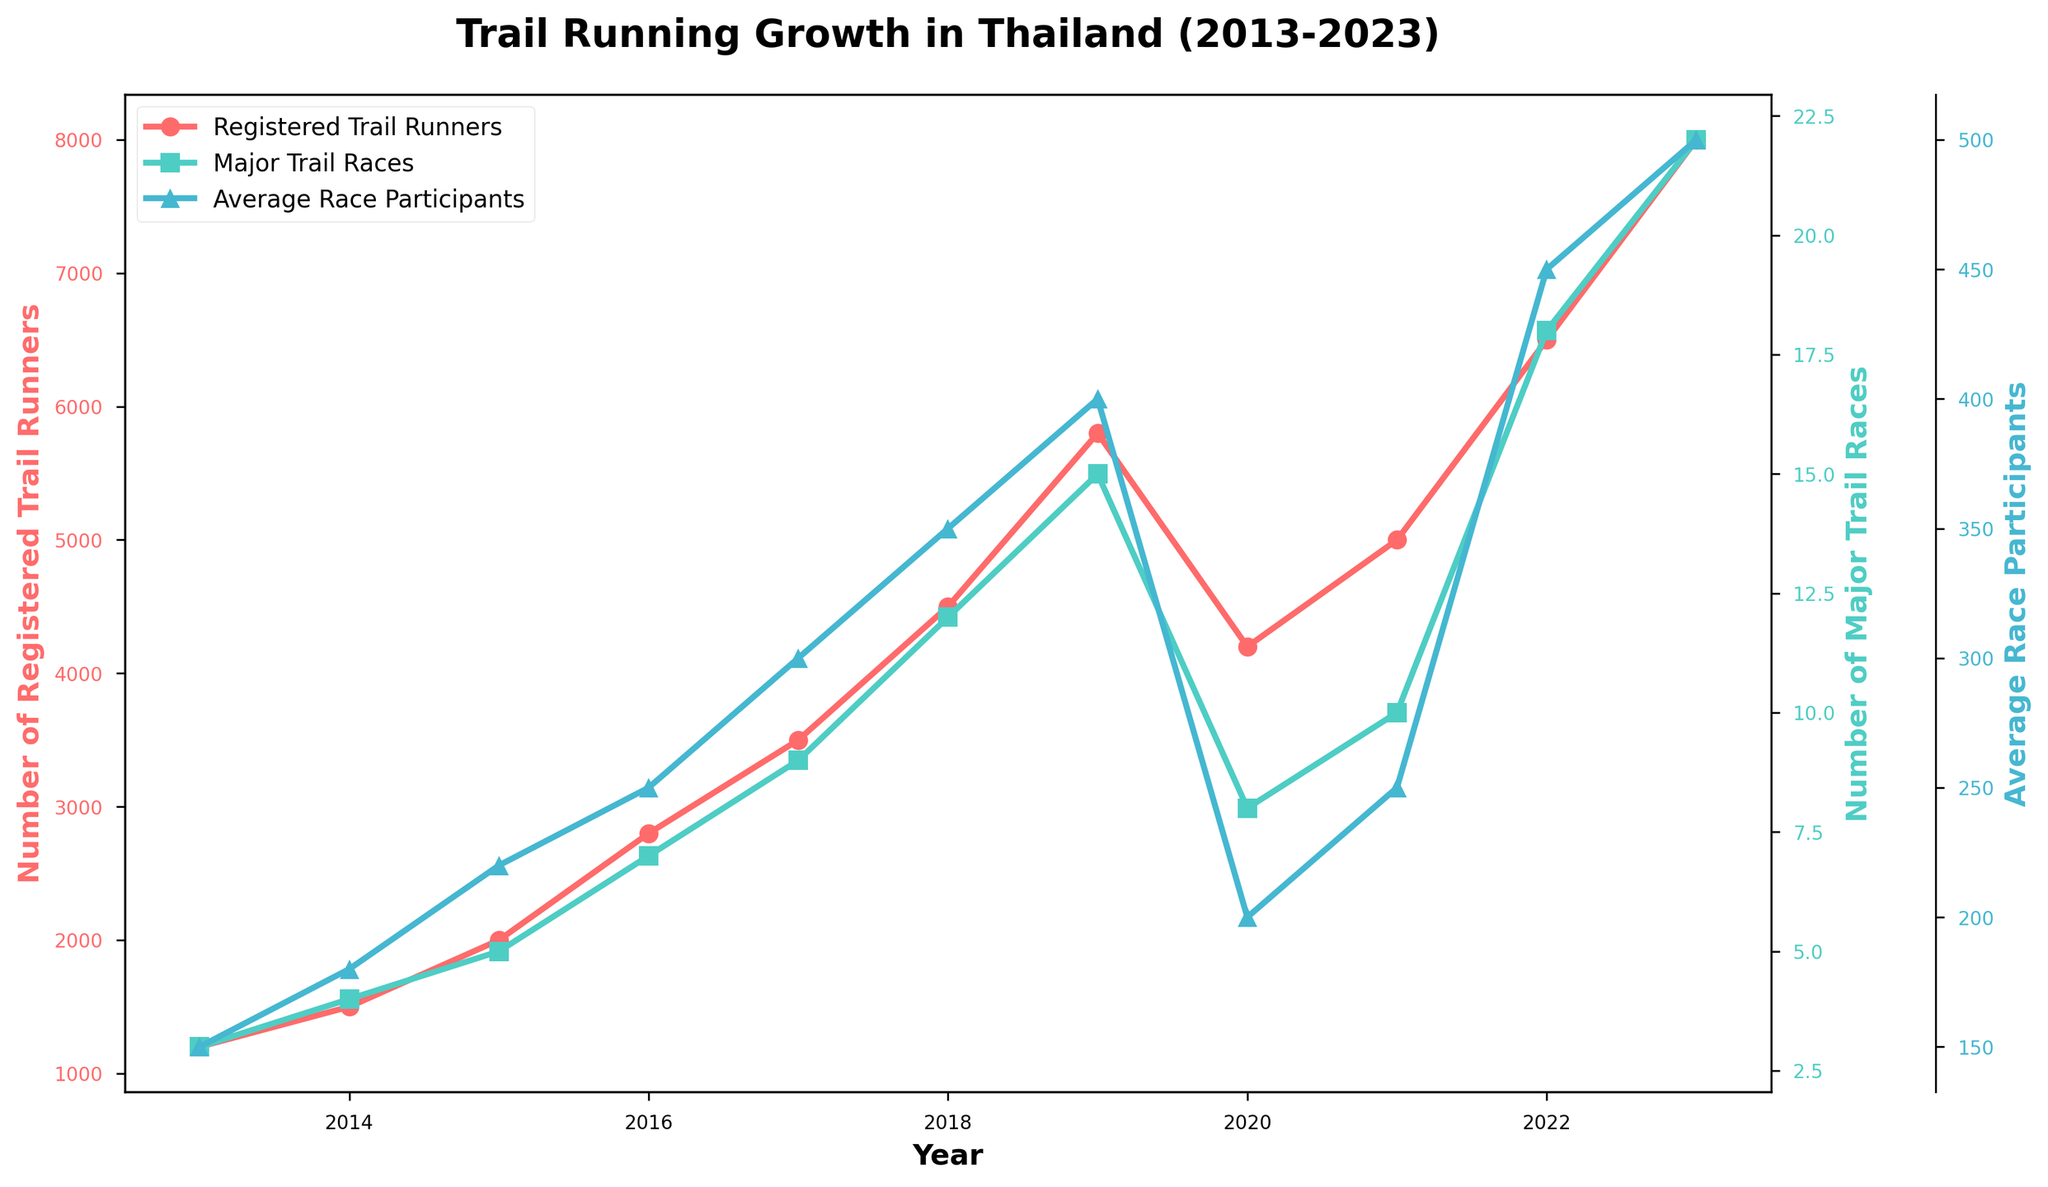What is the trend in the number of registered trail runners from 2013 to 2023? The line representing the number of registered trail runners shows a general upward trend over the years, starting from 1200 in 2013 and reaching 8000 in 2023, with a noticeable dip in 2020.
Answer: Increasing overall Which year experienced the highest number of major trail races? By examining the line representing major trail races, we see that the highest value is in 2023, with 22 major trail races organized.
Answer: 2023 How did the average race participants change between 2019 and 2020? The average race participants dropped from 400 in 2019 to 200 in 2020, as seen from the blue line representing average race participants.
Answer: Decreased by 200 Compare the number of registered trail runners in 2013 and 2023. The number of registered trail runners in 2013 was 1200, and in 2023 it was 8000. The number increased by 8000 - 1200 = 6800 over this period.
Answer: Increased by 6800 Which metric shows a sharp decline in 2020, and what could be a possible reason? All three metrics show a decline in 2020, but the average race participants and the number of registered trail runners show particularly sharp falls. This could be related to the impact of the COVID-19 pandemic.
Answer: Average race participants and Registered trail runners; COVID-19 Calculate the average number of major trail races from 2016 to 2020. The values for major trail races from 2016 to 2020 are 7, 9, 12, 15, and 8. The average is (7 + 9 + 12 + 15 + 8)/5 = 10.2.
Answer: 10.2 What is the difference in the number of registered trail runners between 2018 and 2022? The number of registered trail runners in 2018 was 4500, and in 2022 it was 6500. The difference is 6500 - 4500 = 2000.
Answer: 2000 Which year had the lowest average race participants? The line representing the average race participants shows the lowest value in 2013, with an average of 150 participants.
Answer: 2013 How many more trail running clubs were there in 2023 compared to 2014? The count of trail running clubs in 2014 was 7, and in 2023 it was 45. The difference is 45 - 7 = 38.
Answer: 38 